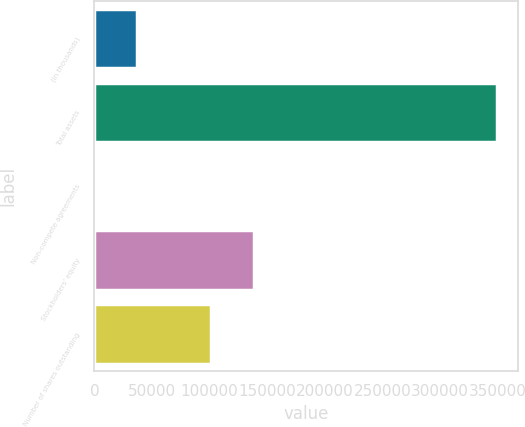<chart> <loc_0><loc_0><loc_500><loc_500><bar_chart><fcel>(in thousands)<fcel>Total assets<fcel>Non-compete agreements<fcel>Stockholders' equity<fcel>Number of shares outstanding<nl><fcel>36551<fcel>349904<fcel>1734<fcel>138774<fcel>101603<nl></chart> 